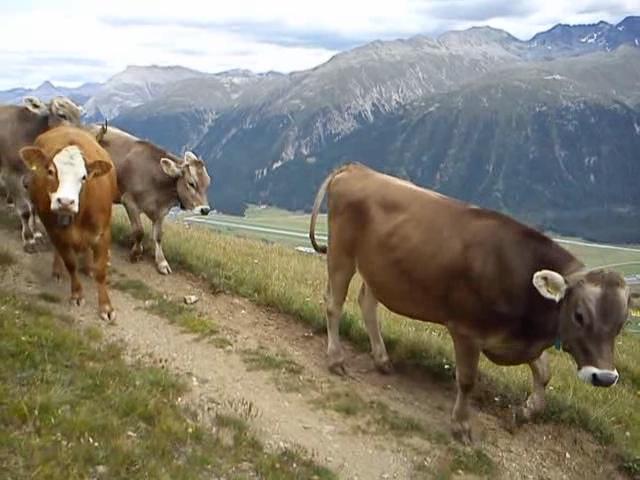Is there something the animals can eat in the photo?
Keep it brief. Yes. Do you see mountains?
Write a very short answer. Yes. Are the animals in a cage?
Keep it brief. No. 